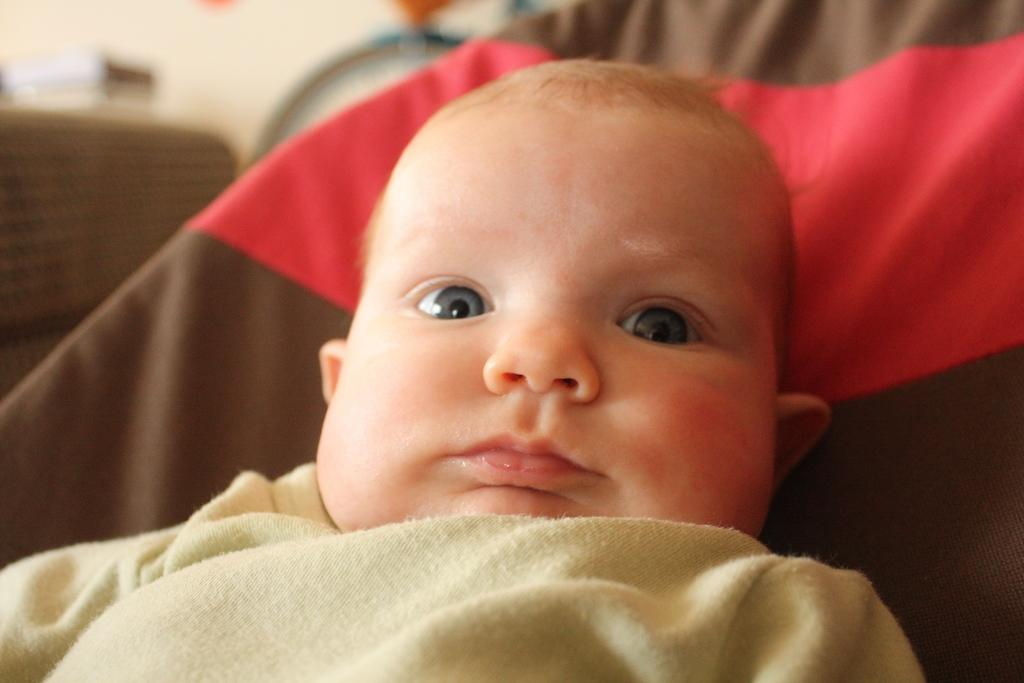What is the main subject of the image? There is a baby in the image. What is the baby lying on? The baby is lying on a cloth. Can you describe the background of the image? The background of the image contains some objects. How would you describe the quality of the image? The image is blurry. What type of pancake is being prepared in the image? There is no pancake present in the image; it features a baby lying on a cloth. Can you tell me how many sheets of paper are visible in the image? There is no paper visible in the image. 